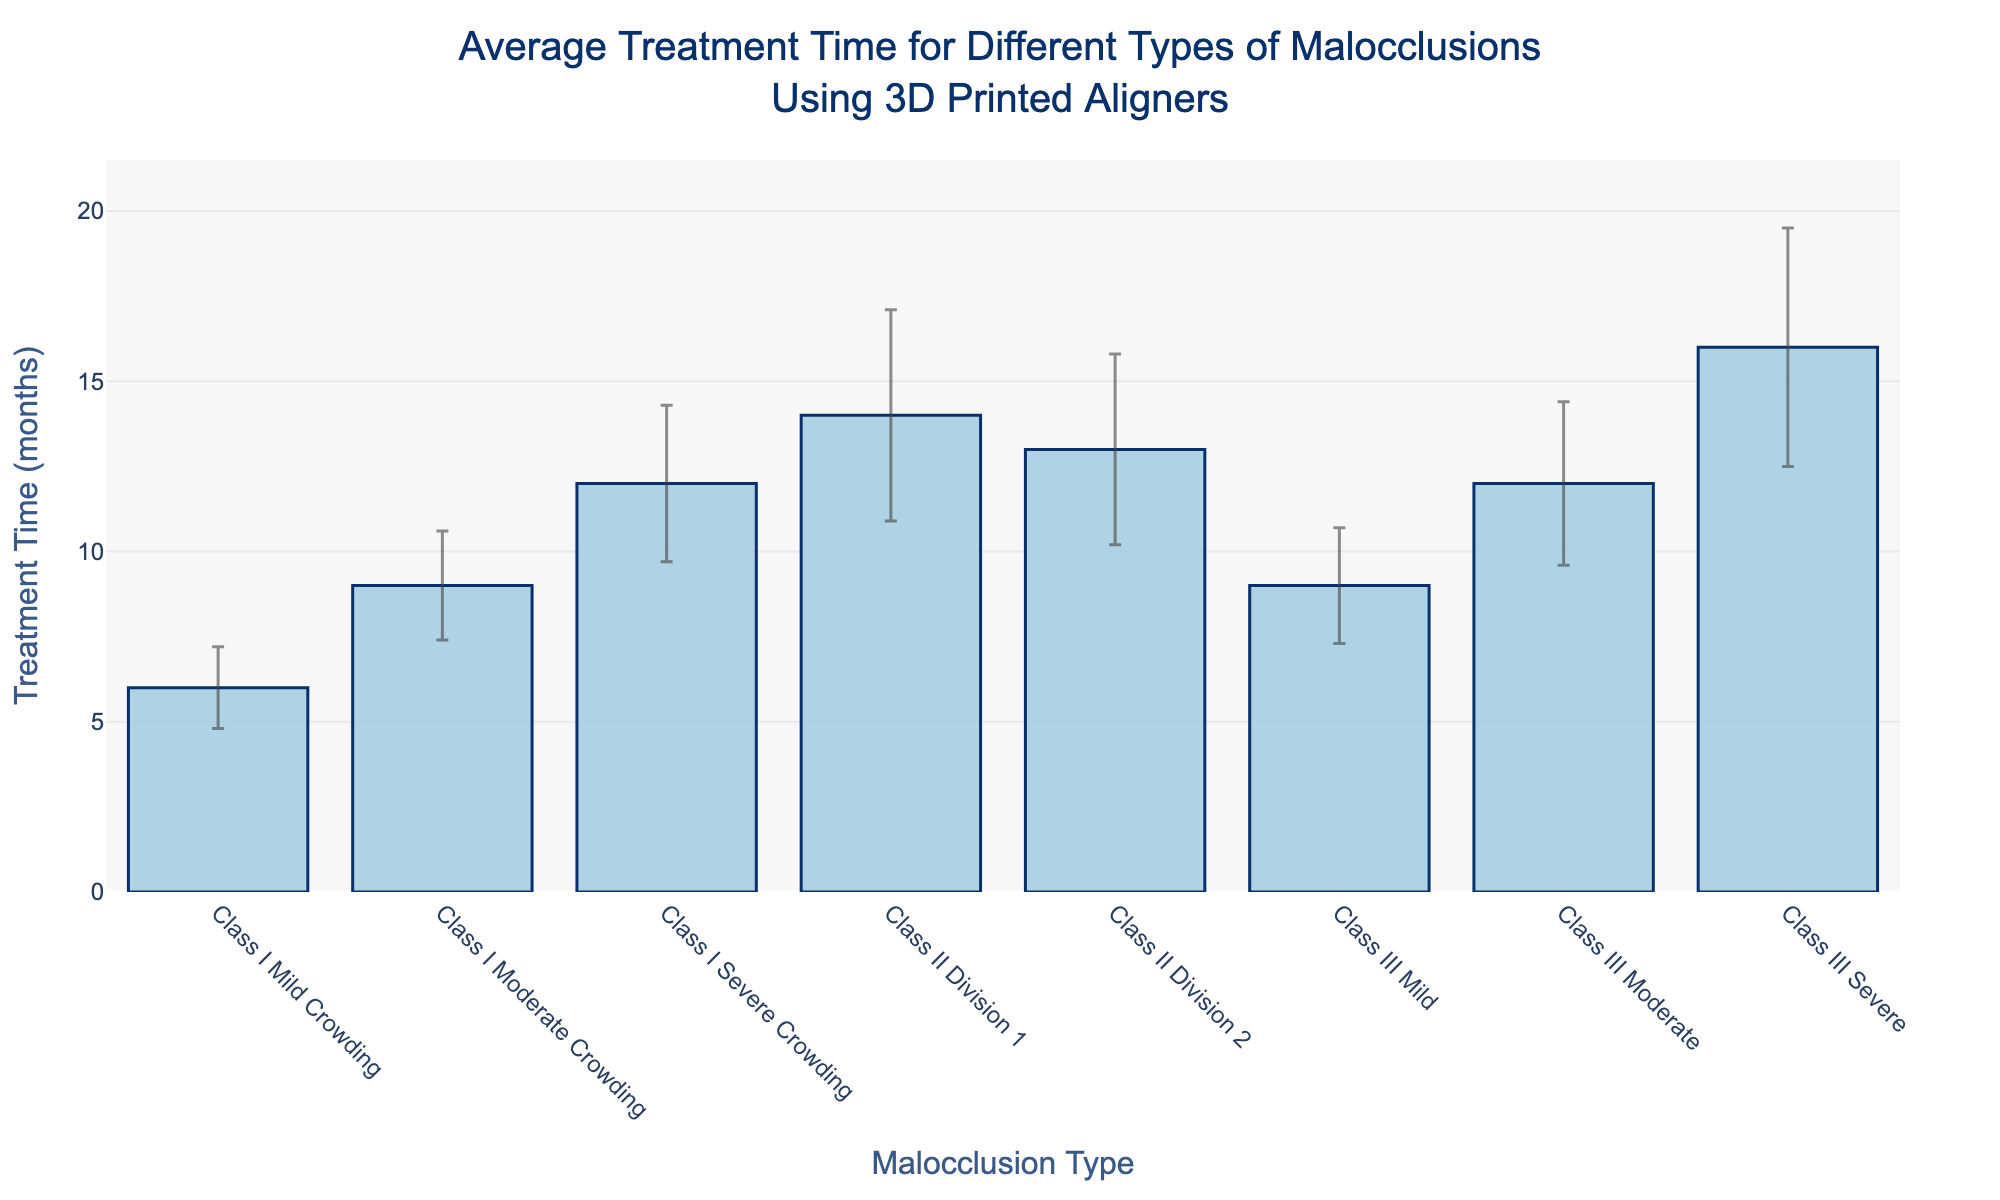What's the title of the figure? The title of the figure is displayed at the top and reads: 'Average Treatment Time for Different Types of Malocclusions Using 3D Printed Aligners'.
Answer: 'Average Treatment Time for Different Types of Malocclusions Using 3D Printed Aligners' What is the mean treatment time for Class II Division 1 malocclusion? The mean treatment time for each malocclusion type is displayed along the y-axis. For Class II Division 1, it is 14 months.
Answer: 14 months Which malocclusion type has the shortest average treatment time and what is it? By comparing the mean treatment times (y-axis values) for all malocclusion types, we see that Class I Mild Crowding has the shortest average treatment time, which is 6 months.
Answer: Class I Mild Crowding, 6 months Which malocclusion type has the largest variability in treatment time and what is the standard deviation? The malocclusion type with the largest error bar indicates the largest variability. Class III Severe has the largest error bar with a standard deviation of 3.5 months.
Answer: Class III Severe, 3.5 months What is the sum of the mean treatment times for Class I Moderate Crowding and Class III Moderate malocclusions? Class I Moderate Crowding has a mean treatment time of 9 months and Class III Moderate has 12 months. Adding these gives 9 + 12 = 21 months.
Answer: 21 months Which malocclusion type shows almost the same mean treatment time but has a higher variability compared to Class I Severe Crowding? Class II Division 2 shows a similar mean treatment time (13 months) compared to Class I Severe (12 months) but higher variability (2.8 months vs 2.3 months).
Answer: Class II Division 2 How does the mean treatment time for Class III Moderate compare to Class I Severe Crowding? Class III Moderate has a mean treatment time of 12 months, while Class I Severe Crowding also has a mean treatment time of 12 months. Therefore, they have the same mean treatment time.
Answer: The same What is the range of treatment times shown on the y-axis? The range of treatment times on the y-axis goes from 0 to the highest mean plus its standard deviation, which is for Class III Severe (16 + 3.5). So the range is approximately 0 to 19.5 months.
Answer: 0 to 19.5 months If we were to group Class I and Class II treatments separately, which group has the higher average mean treatment time? The means for Class I are 6, 9, and 12 months. The average is (6 + 9 + 12) / 3 = 9 months. The means for Class II are 14 and 13 months. The average is (14 + 13) / 2 = 13.5 months. Class II has the higher average mean treatment time.
Answer: Class II What is the difference in variability between Class II Division 1 and Class II Division 2? The standard deviation for Class II Division 1 is 3.1 months and for Class II Division 2 is 2.8 months. The difference in variability is 3.1 - 2.8 = 0.3 months.
Answer: 0.3 months 